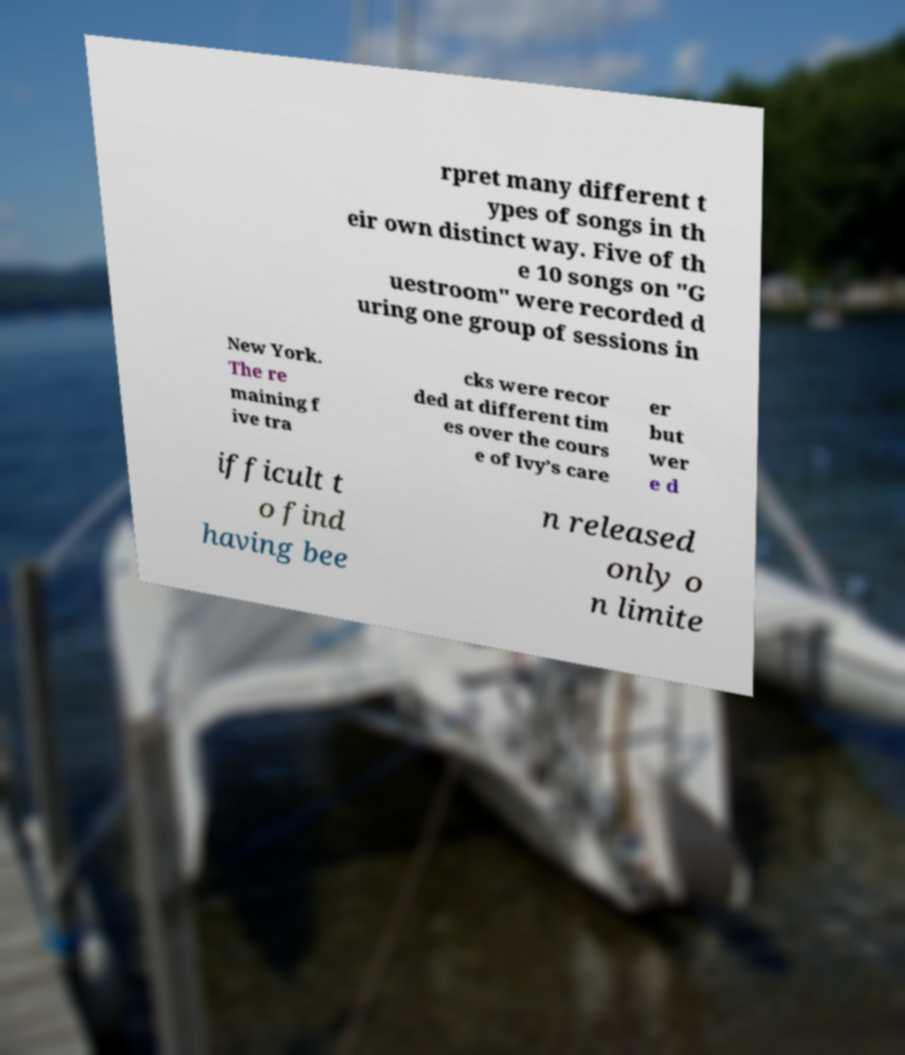There's text embedded in this image that I need extracted. Can you transcribe it verbatim? rpret many different t ypes of songs in th eir own distinct way. Five of th e 10 songs on "G uestroom" were recorded d uring one group of sessions in New York. The re maining f ive tra cks were recor ded at different tim es over the cours e of Ivy’s care er but wer e d ifficult t o find having bee n released only o n limite 